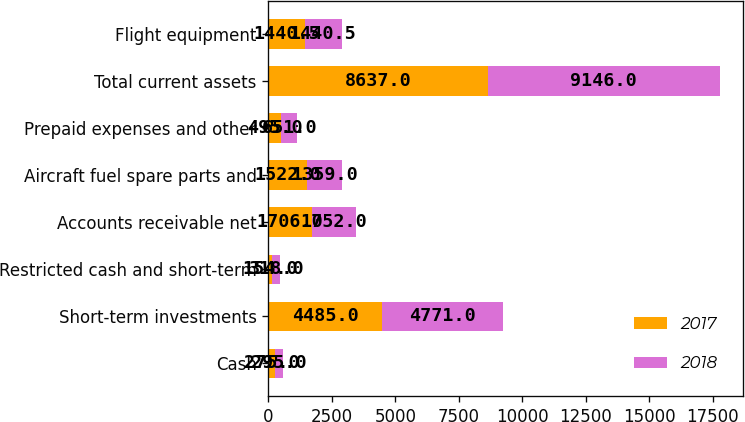Convert chart to OTSL. <chart><loc_0><loc_0><loc_500><loc_500><stacked_bar_chart><ecel><fcel>Cash<fcel>Short-term investments<fcel>Restricted cash and short-term<fcel>Accounts receivable net<fcel>Aircraft fuel spare parts and<fcel>Prepaid expenses and other<fcel>Total current assets<fcel>Flight equipment<nl><fcel>2017<fcel>275<fcel>4485<fcel>154<fcel>1706<fcel>1522<fcel>495<fcel>8637<fcel>1440.5<nl><fcel>2018<fcel>295<fcel>4771<fcel>318<fcel>1752<fcel>1359<fcel>651<fcel>9146<fcel>1440.5<nl></chart> 